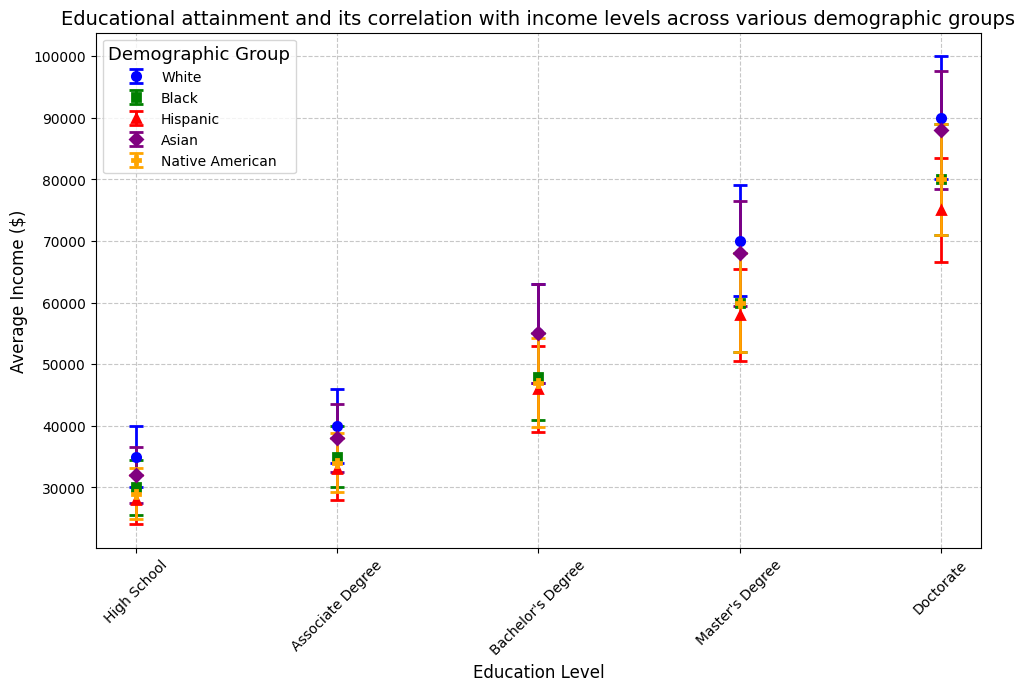What is the average income for Asian individuals with a Bachelor's Degree, and how does it compare to that of Hispanic individuals with the same education level? The average income for Asian individuals with a Bachelor's Degree is $55,000 while for Hispanic individuals it is $46,000. To find the difference, subtract $46,000 from $55,000, which gives $9,000.
Answer: Asians with a Bachelor's Degree earn $9,000 more than Hispanics with the same degree Which demographic group has the highest average income for individuals with a Doctorate degree? The plot shows the average income for individuals with a Doctorate degree across different demographic groups. Asians have the highest average income at $88,000 for this education level.
Answer: Asians Which demographic group shows the largest error bar for individuals with an Associate Degree, and what does it indicate? The plot features the error bars indicating the standard deviation for each group's income levels. For individuals with an Associate Degree, Whites have the largest error bar. This indicates greater variability in income among White individuals with an Associate Degree.
Answer: Whites What is the combined average income for Native American individuals with High School and Bachelor's Degree education levels? The average income for Native American individuals with a High School education is $29,000, and with a Bachelor's Degree, it is $47,000. Adding these two amounts gives $29,000 + $47,000 = $76,000.
Answer: $76,000 Compare the average incomes of individuals with a Master's Degree between Black and White groups. Is one group earning significantly more? The average income for individuals with a Master's Degree is $60,000 for Blacks and $70,000 for Whites. Comparing these values shows that Whites earn $10,000 more on average than Blacks at this education level.
Answer: Whites earn $10,000 more Which educational level shows the smallest income gap between the Hispanic and Black groups? By looking at the plot, compare the income differences for each educational level. The smallest gap is at the Doctorate level, where the average incomes are $75,000 for Hispanics and $80,000 for Blacks, a difference of $5,000.
Answer: Doctorate Which group and education level combination shows the highest variability in income? The largest error bar on the plot indicates the highest variability. The plot shows that White individuals with a Doctorate degree have the largest error bar, indicating the highest income variability.
Answer: Whites with a Doctorate degree How do the average incomes of individuals with a Master's Degree in the Native American group compare to the overall trend of average income increases with education level across all demographic groups? The average income for Native Americans with a Master's Degree is $60,000, fitting the overall trend where higher education levels correlate with increased incomes. This value aligns with the increasing pattern but is generally lower compared to other groups for the same education level.
Answer: Aligns with the trend, generally lower 